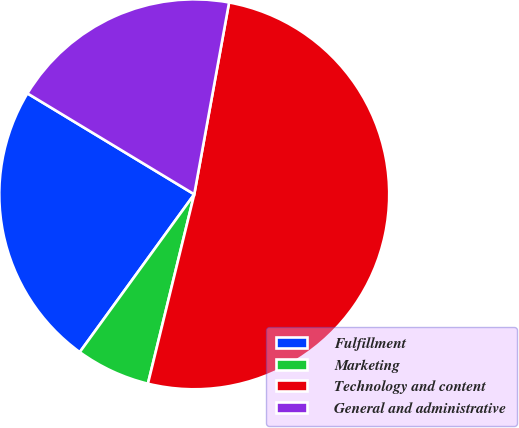Convert chart. <chart><loc_0><loc_0><loc_500><loc_500><pie_chart><fcel>Fulfillment<fcel>Marketing<fcel>Technology and content<fcel>General and administrative<nl><fcel>23.67%<fcel>6.17%<fcel>50.96%<fcel>19.2%<nl></chart> 